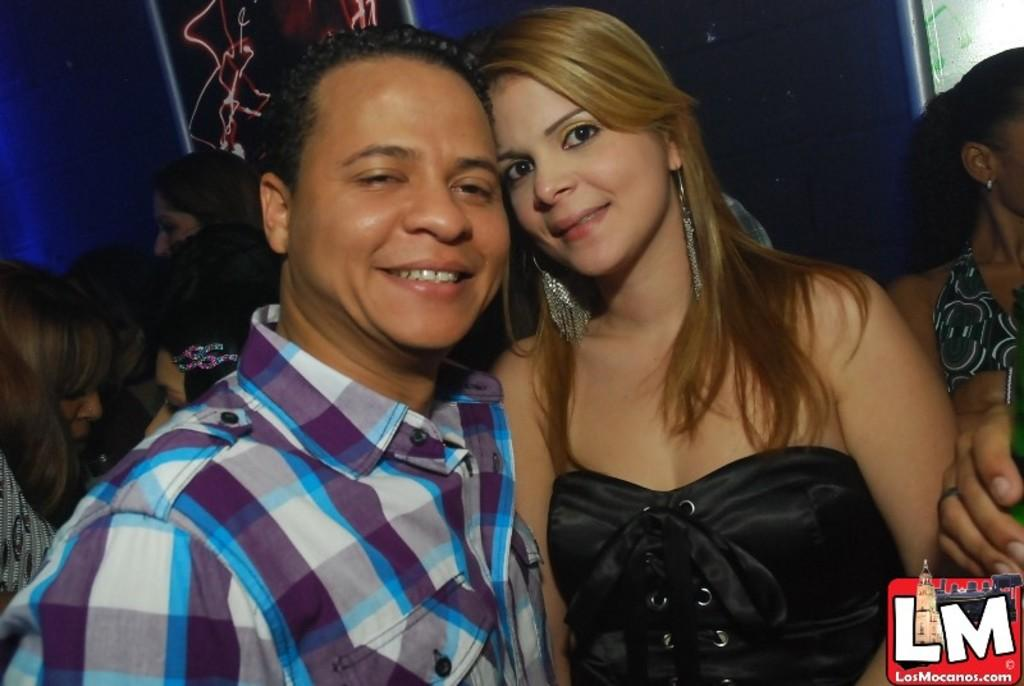How many people are present in the image? There are two people in the image, a man and a woman. What is the facial expression of the man and the woman in the image? Both the man and the woman are smiling in the image. What can be seen in the background of the image? There are people, a wall, and an unspecified object in the background of the image. What type of art is the servant creating in the image? A: There is no servant or art creation present in the image. What is the cause of the man's sore throat in the image? There is no mention of a sore throat or any medical condition in the image. 